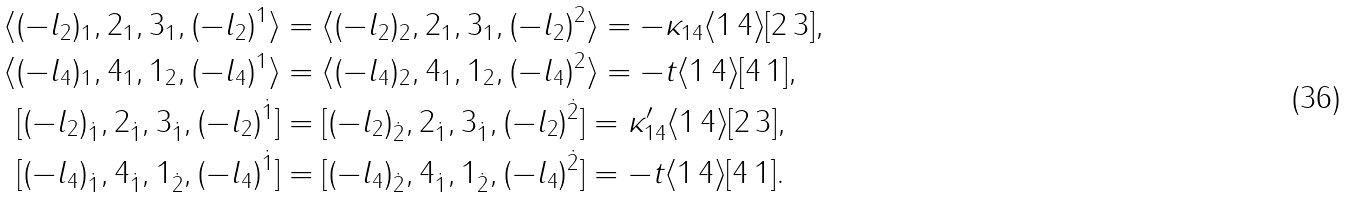Convert formula to latex. <formula><loc_0><loc_0><loc_500><loc_500>\langle ( - l _ { 2 } ) _ { 1 } , 2 _ { 1 } , 3 _ { 1 } , ( - l _ { 2 } ) ^ { 1 } \rangle & = \langle ( - l _ { 2 } ) _ { 2 } , 2 _ { 1 } , 3 _ { 1 } , ( - l _ { 2 } ) ^ { 2 } \rangle = - \kappa _ { 1 4 } \langle 1 \, 4 \rangle [ 2 \, 3 ] , \\ \langle ( - l _ { 4 } ) _ { 1 } , 4 _ { 1 } , 1 _ { 2 } , ( - l _ { 4 } ) ^ { 1 } \rangle & = \langle ( - l _ { 4 } ) _ { 2 } , 4 _ { 1 } , 1 _ { 2 } , ( - l _ { 4 } ) ^ { 2 } \rangle = - t \langle 1 \, 4 \rangle [ 4 \, 1 ] , \\ [ ( - l _ { 2 } ) _ { \dot { 1 } } , 2 _ { \dot { 1 } } , 3 _ { \dot { 1 } } , ( - l _ { 2 } ) ^ { \dot { 1 } } ] & = [ ( - l _ { 2 } ) _ { \dot { 2 } } , 2 _ { \dot { 1 } } , 3 _ { \dot { 1 } } , ( - l _ { 2 } ) ^ { \dot { 2 } } ] = \kappa _ { 1 4 } ^ { \prime } \langle 1 \, 4 \rangle [ 2 \, 3 ] , \\ [ ( - l _ { 4 } ) _ { \dot { 1 } } , 4 _ { \dot { 1 } } , 1 _ { \dot { 2 } } , ( - l _ { 4 } ) ^ { \dot { 1 } } ] & = [ ( - l _ { 4 } ) _ { \dot { 2 } } , 4 _ { \dot { 1 } } , 1 _ { \dot { 2 } } , ( - l _ { 4 } ) ^ { \dot { 2 } } ] = - t \langle 1 \, 4 \rangle [ 4 \, 1 ] .</formula> 